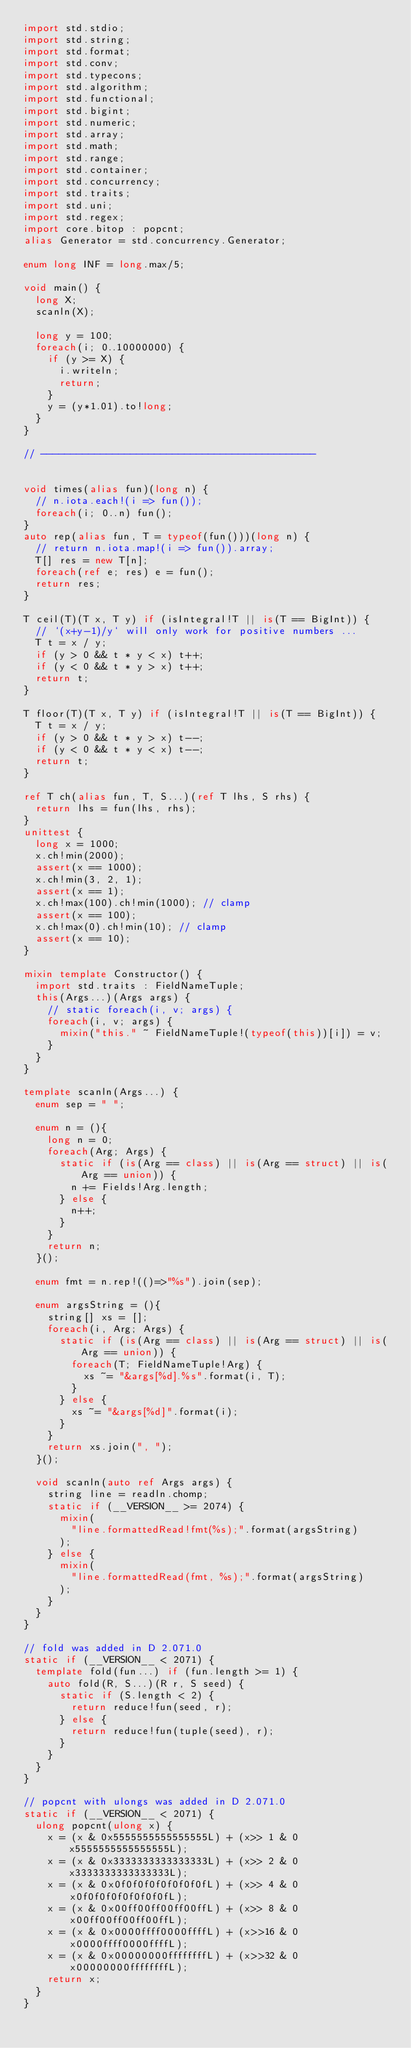Convert code to text. <code><loc_0><loc_0><loc_500><loc_500><_D_>import std.stdio;
import std.string;
import std.format;
import std.conv;
import std.typecons;
import std.algorithm;
import std.functional;
import std.bigint;
import std.numeric;
import std.array;
import std.math;
import std.range;
import std.container;
import std.concurrency;
import std.traits;
import std.uni;
import std.regex;
import core.bitop : popcnt;
alias Generator = std.concurrency.Generator;

enum long INF = long.max/5;

void main() {
  long X;
  scanln(X);

  long y = 100;
  foreach(i; 0..10000000) {
    if (y >= X) {
      i.writeln;
      return;
    }
    y = (y*1.01).to!long;
  }
}

// ----------------------------------------------


void times(alias fun)(long n) {
  // n.iota.each!(i => fun());
  foreach(i; 0..n) fun();
}
auto rep(alias fun, T = typeof(fun()))(long n) {
  // return n.iota.map!(i => fun()).array;
  T[] res = new T[n];
  foreach(ref e; res) e = fun();
  return res;
}

T ceil(T)(T x, T y) if (isIntegral!T || is(T == BigInt)) {
  // `(x+y-1)/y` will only work for positive numbers ...
  T t = x / y;
  if (y > 0 && t * y < x) t++;
  if (y < 0 && t * y > x) t++;
  return t;
}

T floor(T)(T x, T y) if (isIntegral!T || is(T == BigInt)) {
  T t = x / y;
  if (y > 0 && t * y > x) t--;
  if (y < 0 && t * y < x) t--;
  return t;
}

ref T ch(alias fun, T, S...)(ref T lhs, S rhs) {
  return lhs = fun(lhs, rhs);
}
unittest {
  long x = 1000;
  x.ch!min(2000);
  assert(x == 1000);
  x.ch!min(3, 2, 1);
  assert(x == 1);
  x.ch!max(100).ch!min(1000); // clamp
  assert(x == 100);
  x.ch!max(0).ch!min(10); // clamp
  assert(x == 10);
}

mixin template Constructor() {
  import std.traits : FieldNameTuple;
  this(Args...)(Args args) {
    // static foreach(i, v; args) {
    foreach(i, v; args) {
      mixin("this." ~ FieldNameTuple!(typeof(this))[i]) = v;
    }
  }
}

template scanln(Args...) {
  enum sep = " ";

  enum n = (){
    long n = 0;
    foreach(Arg; Args) {
      static if (is(Arg == class) || is(Arg == struct) || is(Arg == union)) {
        n += Fields!Arg.length;
      } else {
        n++;
      }
    }
    return n;
  }();

  enum fmt = n.rep!(()=>"%s").join(sep);

  enum argsString = (){
    string[] xs = [];
    foreach(i, Arg; Args) {
      static if (is(Arg == class) || is(Arg == struct) || is(Arg == union)) {
        foreach(T; FieldNameTuple!Arg) {
          xs ~= "&args[%d].%s".format(i, T);
        }
      } else {
        xs ~= "&args[%d]".format(i);
      }
    }
    return xs.join(", ");
  }();

  void scanln(auto ref Args args) {
    string line = readln.chomp;
    static if (__VERSION__ >= 2074) {
      mixin(
        "line.formattedRead!fmt(%s);".format(argsString)
      );
    } else {
      mixin(
        "line.formattedRead(fmt, %s);".format(argsString)
      );
    }
  }
}

// fold was added in D 2.071.0
static if (__VERSION__ < 2071) {
  template fold(fun...) if (fun.length >= 1) {
    auto fold(R, S...)(R r, S seed) {
      static if (S.length < 2) {
        return reduce!fun(seed, r);
      } else {
        return reduce!fun(tuple(seed), r);
      }
    }
  }
}

// popcnt with ulongs was added in D 2.071.0
static if (__VERSION__ < 2071) {
  ulong popcnt(ulong x) {
    x = (x & 0x5555555555555555L) + (x>> 1 & 0x5555555555555555L);
    x = (x & 0x3333333333333333L) + (x>> 2 & 0x3333333333333333L);
    x = (x & 0x0f0f0f0f0f0f0f0fL) + (x>> 4 & 0x0f0f0f0f0f0f0f0fL);
    x = (x & 0x00ff00ff00ff00ffL) + (x>> 8 & 0x00ff00ff00ff00ffL);
    x = (x & 0x0000ffff0000ffffL) + (x>>16 & 0x0000ffff0000ffffL);
    x = (x & 0x00000000ffffffffL) + (x>>32 & 0x00000000ffffffffL);
    return x;
  }
}
</code> 